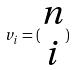<formula> <loc_0><loc_0><loc_500><loc_500>v _ { i } = ( \begin{matrix} n \\ i \end{matrix} )</formula> 